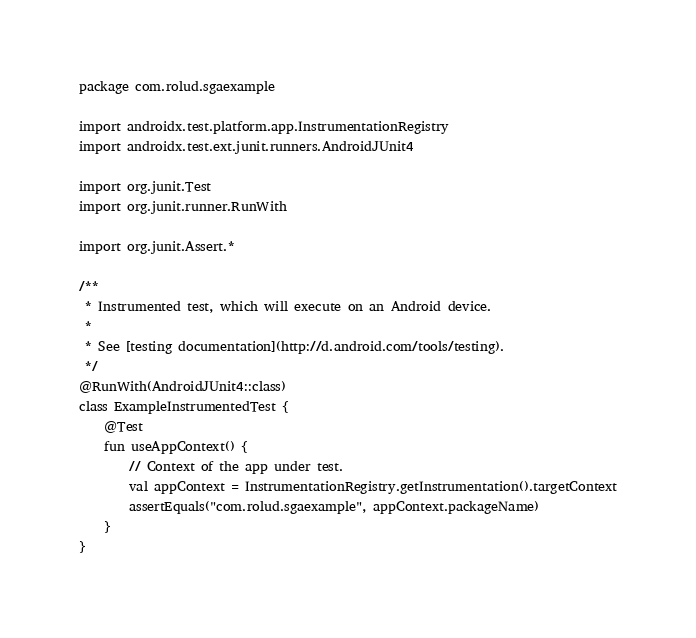<code> <loc_0><loc_0><loc_500><loc_500><_Kotlin_>package com.rolud.sgaexample

import androidx.test.platform.app.InstrumentationRegistry
import androidx.test.ext.junit.runners.AndroidJUnit4

import org.junit.Test
import org.junit.runner.RunWith

import org.junit.Assert.*

/**
 * Instrumented test, which will execute on an Android device.
 *
 * See [testing documentation](http://d.android.com/tools/testing).
 */
@RunWith(AndroidJUnit4::class)
class ExampleInstrumentedTest {
    @Test
    fun useAppContext() {
        // Context of the app under test.
        val appContext = InstrumentationRegistry.getInstrumentation().targetContext
        assertEquals("com.rolud.sgaexample", appContext.packageName)
    }
}
</code> 